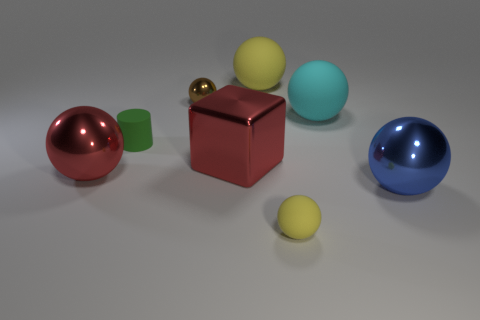Add 7 tiny green cylinders. How many tiny green cylinders exist? 8 Add 1 big cyan balls. How many objects exist? 9 Subtract all yellow balls. How many balls are left? 4 Subtract all big cyan spheres. How many spheres are left? 5 Subtract 1 brown balls. How many objects are left? 7 Subtract all blocks. How many objects are left? 7 Subtract 1 blocks. How many blocks are left? 0 Subtract all gray blocks. Subtract all red balls. How many blocks are left? 1 Subtract all blue cylinders. How many blue cubes are left? 0 Subtract all big blue rubber spheres. Subtract all cyan spheres. How many objects are left? 7 